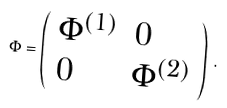Convert formula to latex. <formula><loc_0><loc_0><loc_500><loc_500>\Phi = \left ( \begin{array} { l l } { { \Phi ^ { ( 1 ) } } } & { 0 } \\ { 0 } & { { \Phi ^ { ( 2 ) } } } \end{array} \right ) \, .</formula> 